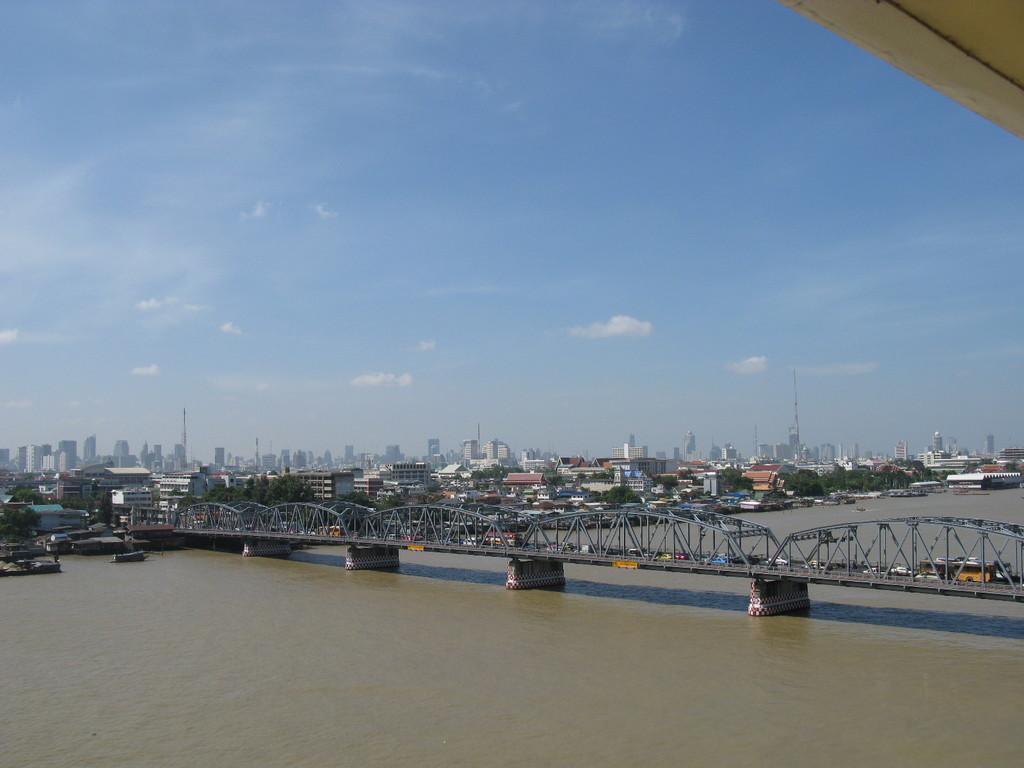What is happening on the bridge in the image? There are vehicles on a bridge in the image. What is the bridge crossing over? The bridge is across a river. What can be seen in the background of the image? There are buildings, trees, and the sky visible in the background of the image. What type of joke is being told by the robin in the image? There is no robin present in the image, so no joke can be observed. 